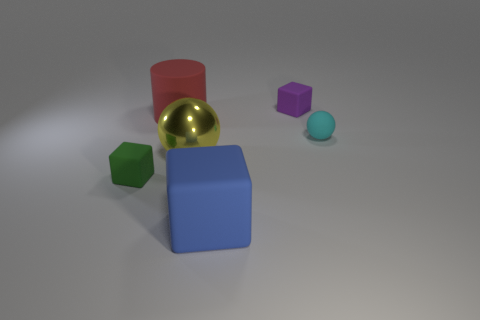Add 2 red cylinders. How many objects exist? 8 Subtract all balls. How many objects are left? 4 Add 5 large blue metallic blocks. How many large blue metallic blocks exist? 5 Subtract 0 gray cubes. How many objects are left? 6 Subtract all yellow metallic cylinders. Subtract all big red matte things. How many objects are left? 5 Add 1 red things. How many red things are left? 2 